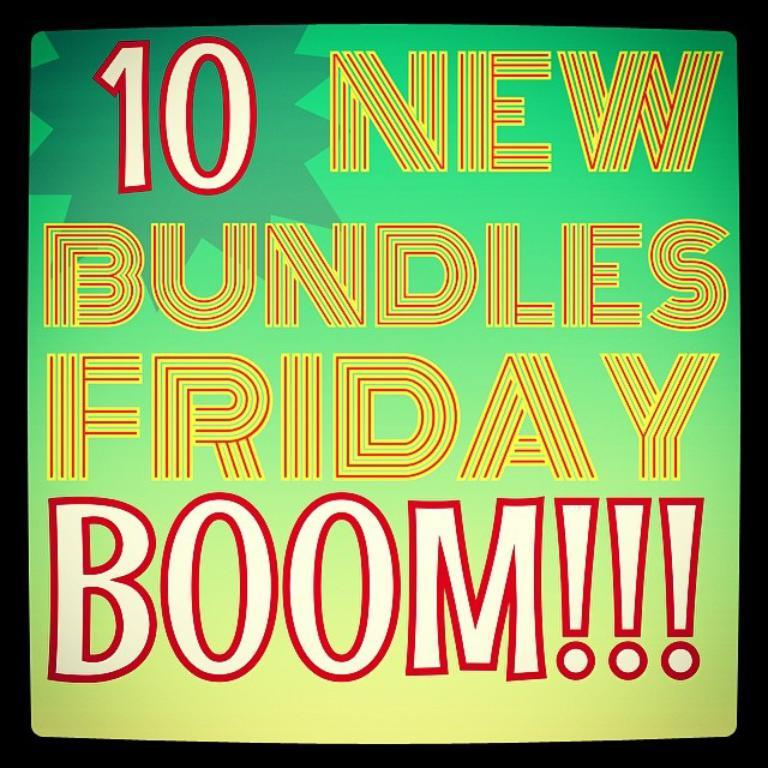Provide a one-sentence caption for the provided image. A green and yellow sign that advertises 10 New Bundles Friday. 